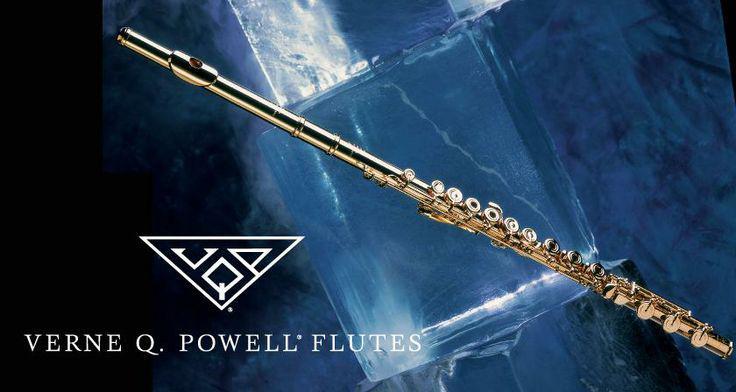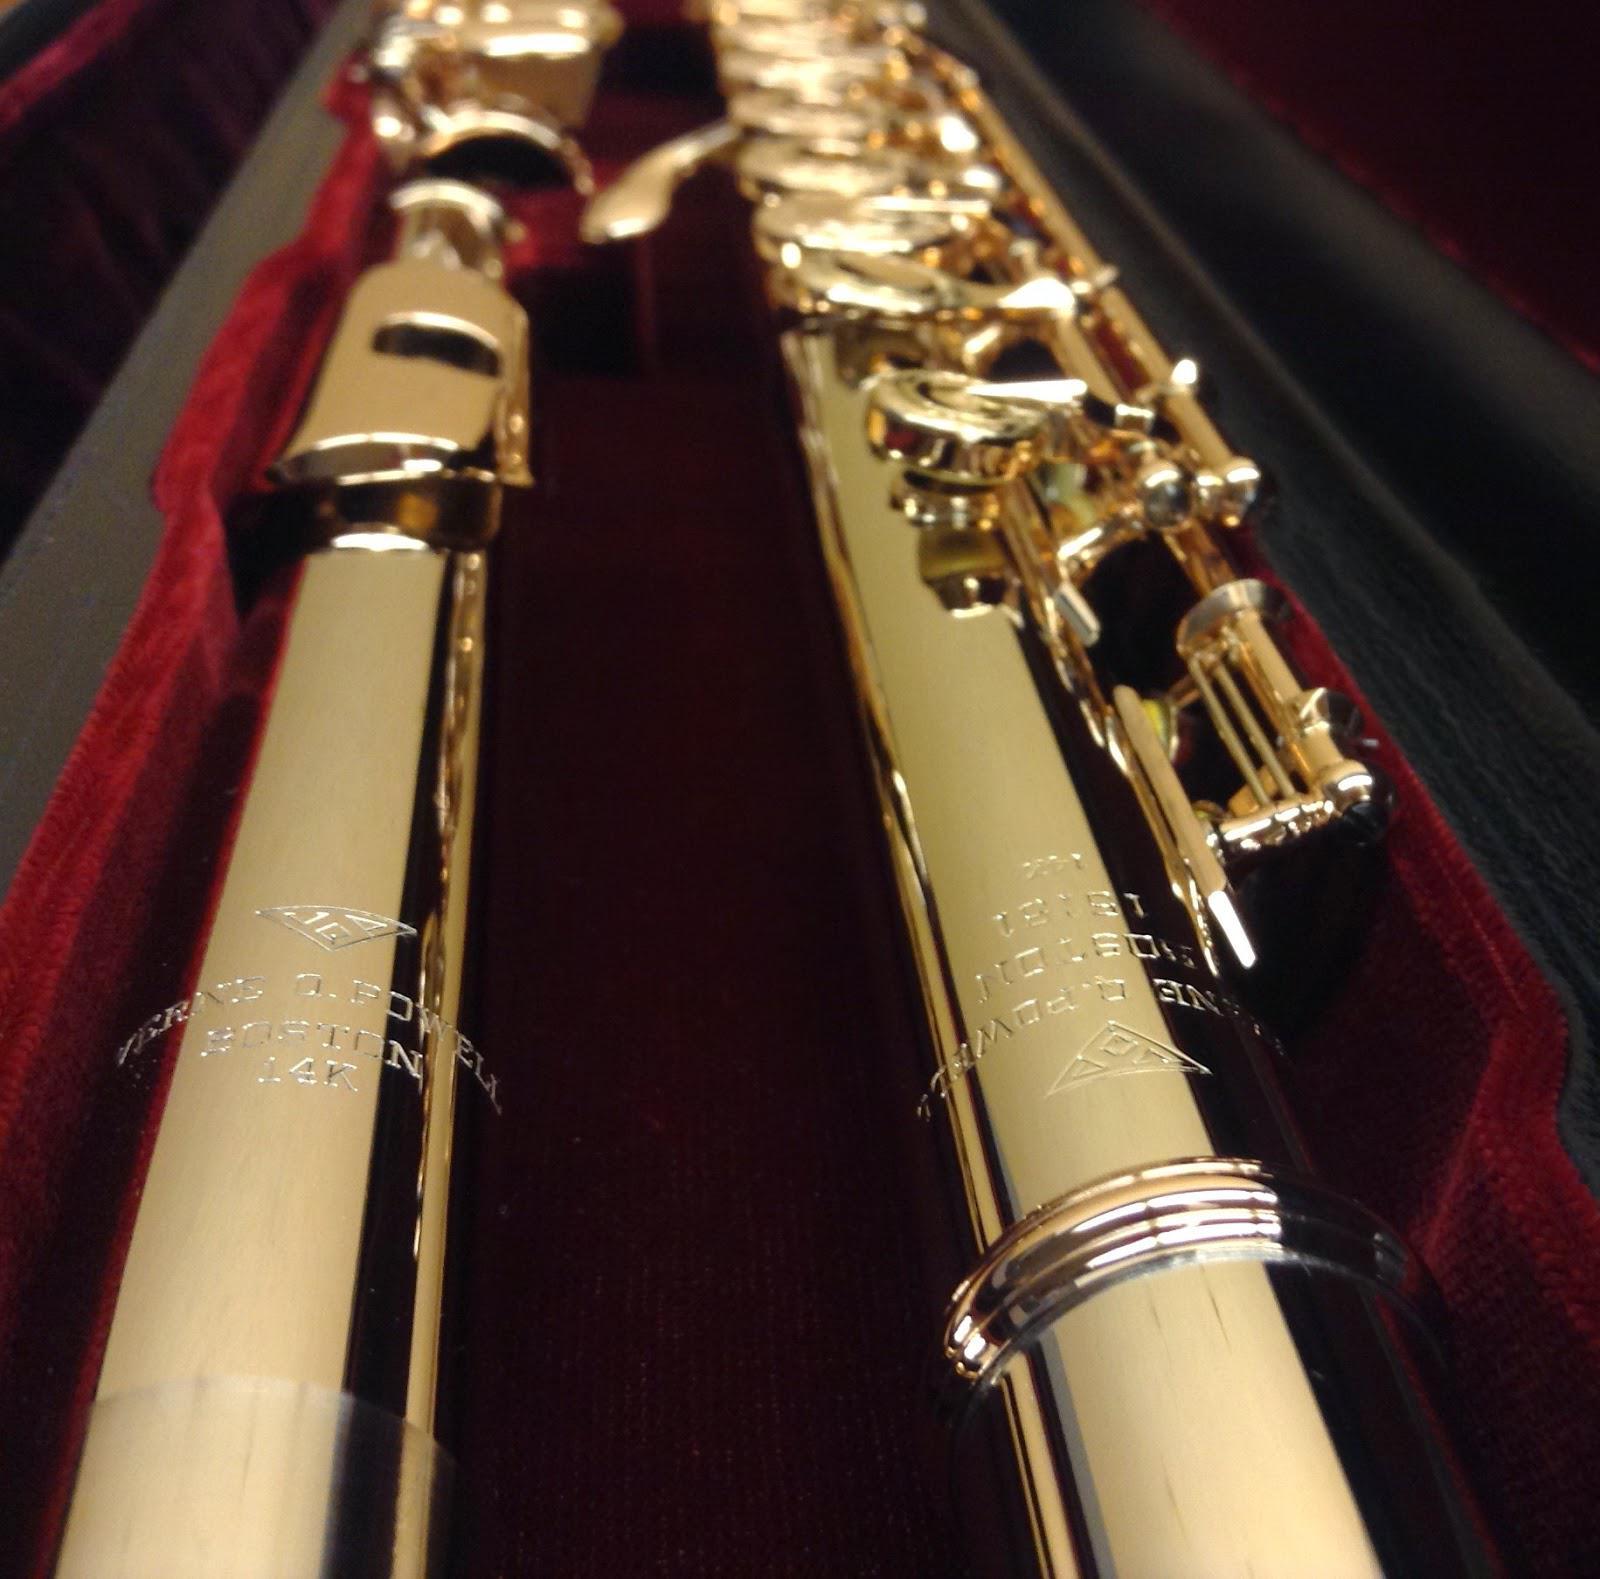The first image is the image on the left, the second image is the image on the right. For the images shown, is this caption "There are exactly two flutes in the right image." true? Answer yes or no. Yes. The first image is the image on the left, the second image is the image on the right. Considering the images on both sides, is "There is only one instrument in the left image." valid? Answer yes or no. Yes. 